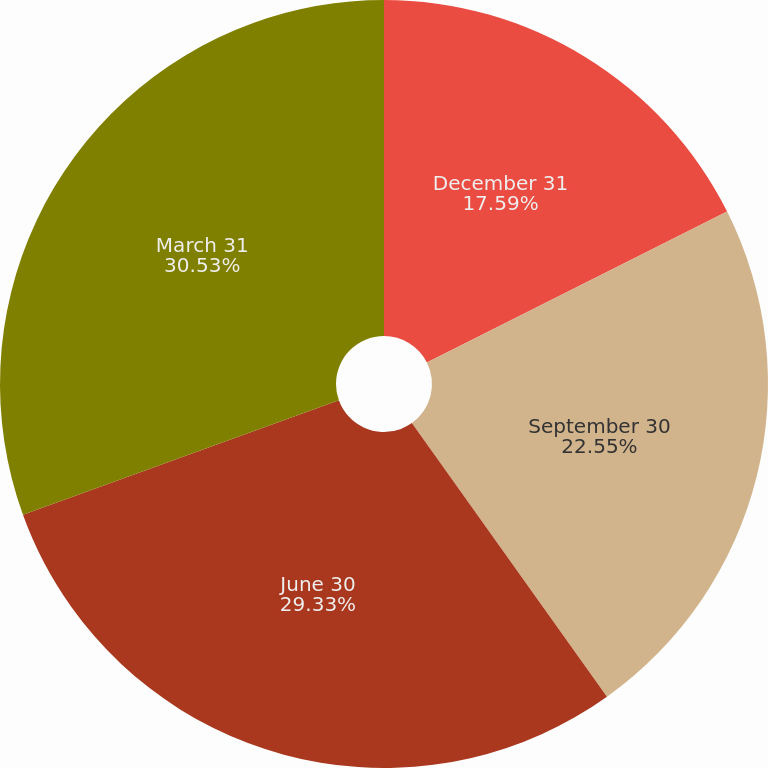<chart> <loc_0><loc_0><loc_500><loc_500><pie_chart><fcel>December 31<fcel>September 30<fcel>June 30<fcel>March 31<nl><fcel>17.59%<fcel>22.55%<fcel>29.33%<fcel>30.53%<nl></chart> 